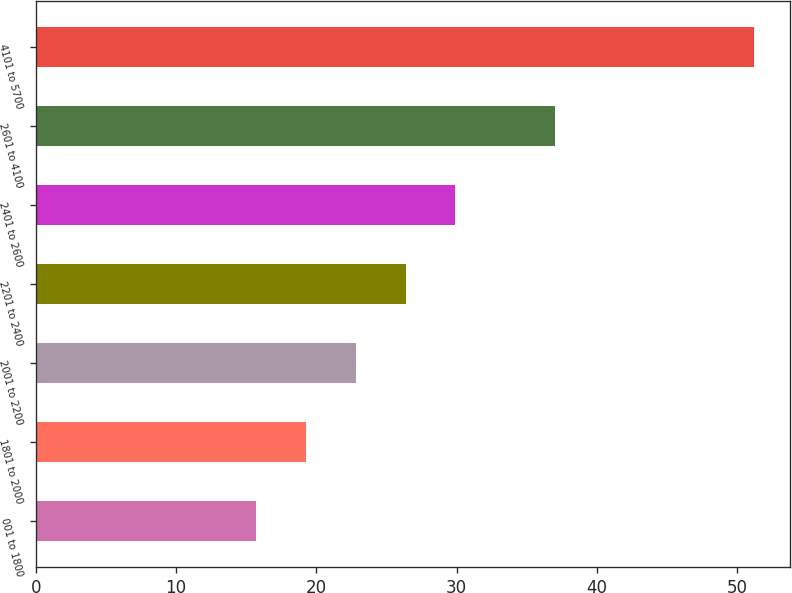Convert chart to OTSL. <chart><loc_0><loc_0><loc_500><loc_500><bar_chart><fcel>001 to 1800<fcel>1801 to 2000<fcel>2001 to 2200<fcel>2201 to 2400<fcel>2401 to 2600<fcel>2601 to 4100<fcel>4101 to 5700<nl><fcel>15.68<fcel>19.25<fcel>22.8<fcel>26.35<fcel>29.9<fcel>36.97<fcel>51.19<nl></chart> 